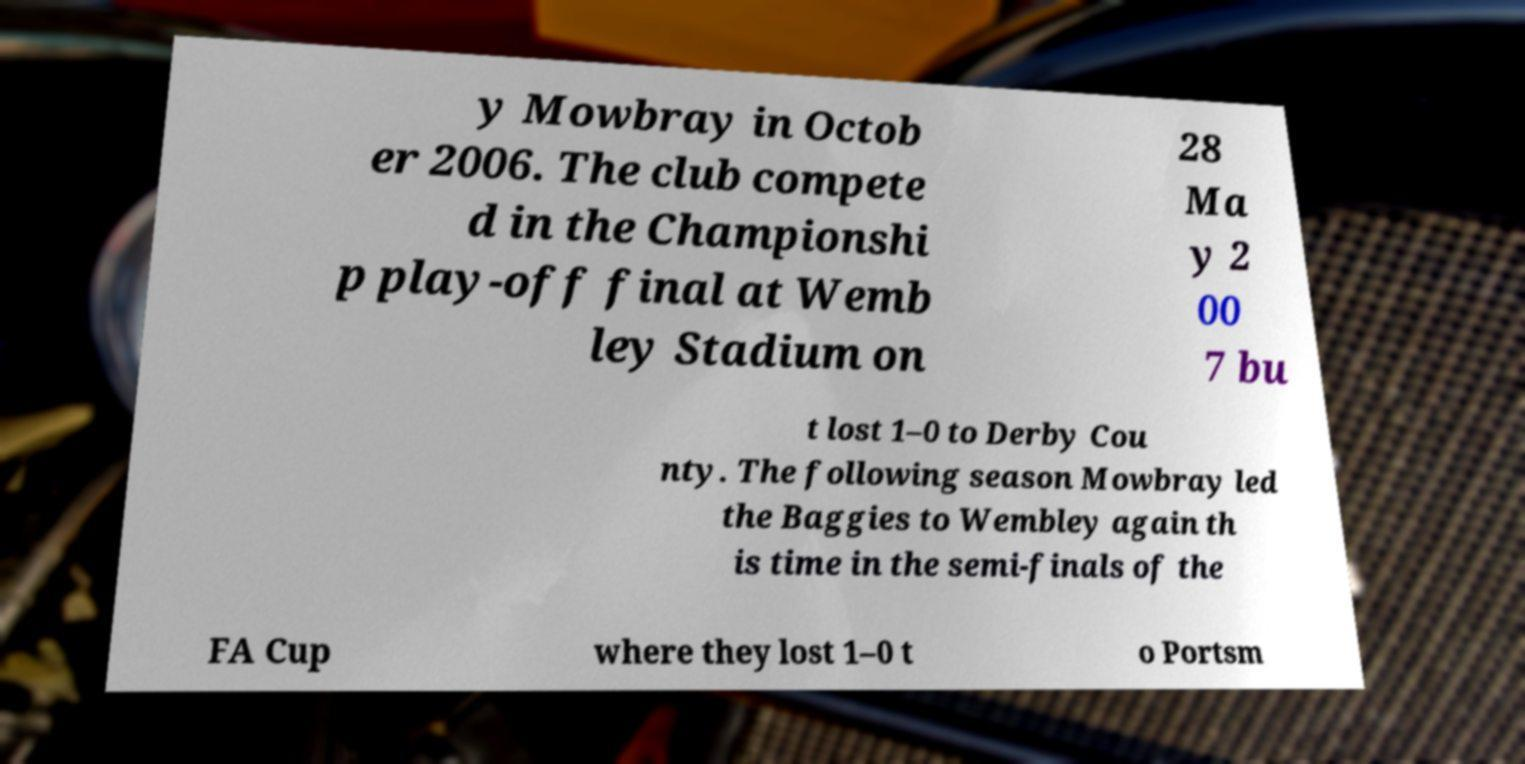I need the written content from this picture converted into text. Can you do that? y Mowbray in Octob er 2006. The club compete d in the Championshi p play-off final at Wemb ley Stadium on 28 Ma y 2 00 7 bu t lost 1–0 to Derby Cou nty. The following season Mowbray led the Baggies to Wembley again th is time in the semi-finals of the FA Cup where they lost 1–0 t o Portsm 